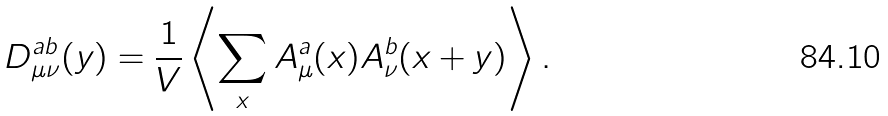Convert formula to latex. <formula><loc_0><loc_0><loc_500><loc_500>D _ { \mu \nu } ^ { a b } ( y ) = \frac { 1 } { V } \left \langle \sum _ { x } A _ { \mu } ^ { a } ( x ) A _ { \nu } ^ { b } ( x + y ) \right \rangle .</formula> 